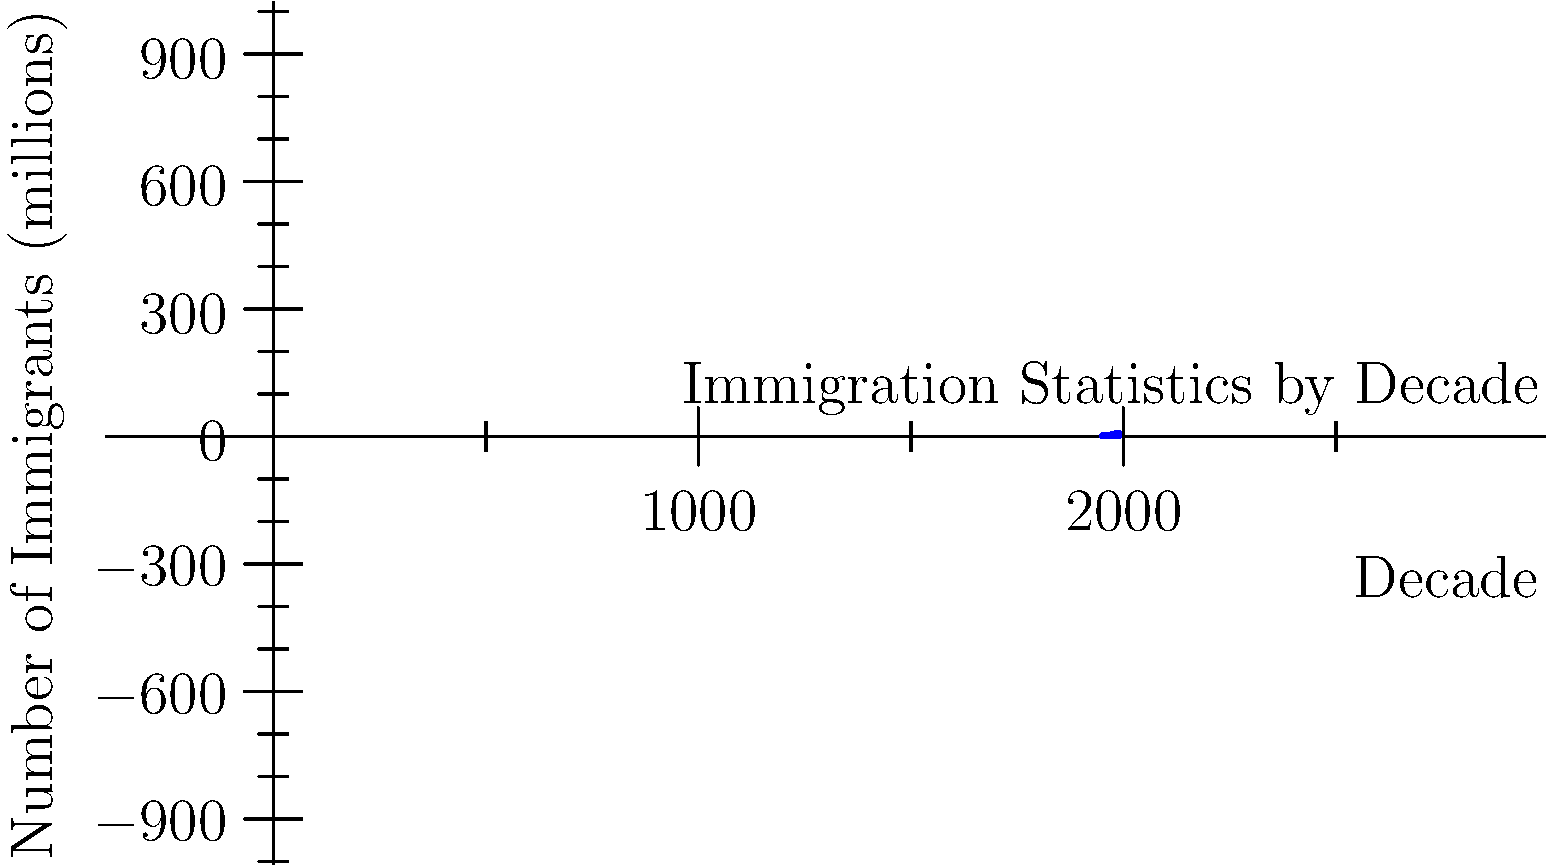Based on the bar graph showing immigration statistics across different decades, which decade saw the largest increase in the number of immigrants compared to the previous decade? To determine which decade had the largest increase in immigrants compared to the previous decade, we need to calculate the difference between each consecutive pair of decades and compare:

1. 1950s to 1960s: $3.3 - 2.5 = 0.8$ million
2. 1960s to 1970s: $4.5 - 3.3 = 1.2$ million
3. 1970s to 1980s: $7.3 - 4.5 = 2.8$ million
4. 1980s to 1990s: $9.0 - 7.3 = 1.7$ million

The largest increase is 2.8 million, which occurred between the 1970s and 1980s.
Answer: 1980s 